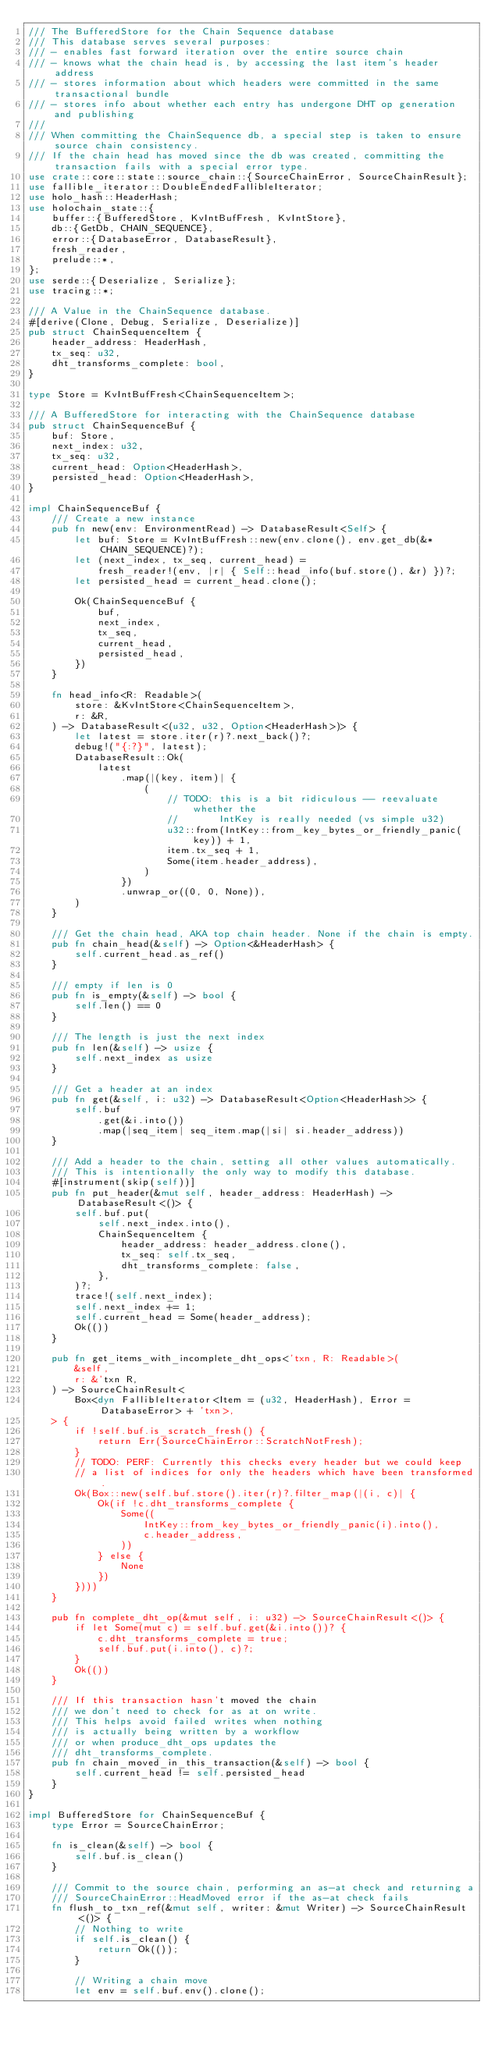<code> <loc_0><loc_0><loc_500><loc_500><_Rust_>/// The BufferedStore for the Chain Sequence database
/// This database serves several purposes:
/// - enables fast forward iteration over the entire source chain
/// - knows what the chain head is, by accessing the last item's header address
/// - stores information about which headers were committed in the same transactional bundle
/// - stores info about whether each entry has undergone DHT op generation and publishing
///
/// When committing the ChainSequence db, a special step is taken to ensure source chain consistency.
/// If the chain head has moved since the db was created, committing the transaction fails with a special error type.
use crate::core::state::source_chain::{SourceChainError, SourceChainResult};
use fallible_iterator::DoubleEndedFallibleIterator;
use holo_hash::HeaderHash;
use holochain_state::{
    buffer::{BufferedStore, KvIntBufFresh, KvIntStore},
    db::{GetDb, CHAIN_SEQUENCE},
    error::{DatabaseError, DatabaseResult},
    fresh_reader,
    prelude::*,
};
use serde::{Deserialize, Serialize};
use tracing::*;

/// A Value in the ChainSequence database.
#[derive(Clone, Debug, Serialize, Deserialize)]
pub struct ChainSequenceItem {
    header_address: HeaderHash,
    tx_seq: u32,
    dht_transforms_complete: bool,
}

type Store = KvIntBufFresh<ChainSequenceItem>;

/// A BufferedStore for interacting with the ChainSequence database
pub struct ChainSequenceBuf {
    buf: Store,
    next_index: u32,
    tx_seq: u32,
    current_head: Option<HeaderHash>,
    persisted_head: Option<HeaderHash>,
}

impl ChainSequenceBuf {
    /// Create a new instance
    pub fn new(env: EnvironmentRead) -> DatabaseResult<Self> {
        let buf: Store = KvIntBufFresh::new(env.clone(), env.get_db(&*CHAIN_SEQUENCE)?);
        let (next_index, tx_seq, current_head) =
            fresh_reader!(env, |r| { Self::head_info(buf.store(), &r) })?;
        let persisted_head = current_head.clone();

        Ok(ChainSequenceBuf {
            buf,
            next_index,
            tx_seq,
            current_head,
            persisted_head,
        })
    }

    fn head_info<R: Readable>(
        store: &KvIntStore<ChainSequenceItem>,
        r: &R,
    ) -> DatabaseResult<(u32, u32, Option<HeaderHash>)> {
        let latest = store.iter(r)?.next_back()?;
        debug!("{:?}", latest);
        DatabaseResult::Ok(
            latest
                .map(|(key, item)| {
                    (
                        // TODO: this is a bit ridiculous -- reevaluate whether the
                        //       IntKey is really needed (vs simple u32)
                        u32::from(IntKey::from_key_bytes_or_friendly_panic(key)) + 1,
                        item.tx_seq + 1,
                        Some(item.header_address),
                    )
                })
                .unwrap_or((0, 0, None)),
        )
    }

    /// Get the chain head, AKA top chain header. None if the chain is empty.
    pub fn chain_head(&self) -> Option<&HeaderHash> {
        self.current_head.as_ref()
    }

    /// empty if len is 0
    pub fn is_empty(&self) -> bool {
        self.len() == 0
    }

    /// The length is just the next index
    pub fn len(&self) -> usize {
        self.next_index as usize
    }

    /// Get a header at an index
    pub fn get(&self, i: u32) -> DatabaseResult<Option<HeaderHash>> {
        self.buf
            .get(&i.into())
            .map(|seq_item| seq_item.map(|si| si.header_address))
    }

    /// Add a header to the chain, setting all other values automatically.
    /// This is intentionally the only way to modify this database.
    #[instrument(skip(self))]
    pub fn put_header(&mut self, header_address: HeaderHash) -> DatabaseResult<()> {
        self.buf.put(
            self.next_index.into(),
            ChainSequenceItem {
                header_address: header_address.clone(),
                tx_seq: self.tx_seq,
                dht_transforms_complete: false,
            },
        )?;
        trace!(self.next_index);
        self.next_index += 1;
        self.current_head = Some(header_address);
        Ok(())
    }

    pub fn get_items_with_incomplete_dht_ops<'txn, R: Readable>(
        &self,
        r: &'txn R,
    ) -> SourceChainResult<
        Box<dyn FallibleIterator<Item = (u32, HeaderHash), Error = DatabaseError> + 'txn>,
    > {
        if !self.buf.is_scratch_fresh() {
            return Err(SourceChainError::ScratchNotFresh);
        }
        // TODO: PERF: Currently this checks every header but we could keep
        // a list of indices for only the headers which have been transformed.
        Ok(Box::new(self.buf.store().iter(r)?.filter_map(|(i, c)| {
            Ok(if !c.dht_transforms_complete {
                Some((
                    IntKey::from_key_bytes_or_friendly_panic(i).into(),
                    c.header_address,
                ))
            } else {
                None
            })
        })))
    }

    pub fn complete_dht_op(&mut self, i: u32) -> SourceChainResult<()> {
        if let Some(mut c) = self.buf.get(&i.into())? {
            c.dht_transforms_complete = true;
            self.buf.put(i.into(), c)?;
        }
        Ok(())
    }

    /// If this transaction hasn't moved the chain
    /// we don't need to check for as at on write.
    /// This helps avoid failed writes when nothing
    /// is actually being written by a workflow
    /// or when produce_dht_ops updates the
    /// dht_transforms_complete.
    pub fn chain_moved_in_this_transaction(&self) -> bool {
        self.current_head != self.persisted_head
    }
}

impl BufferedStore for ChainSequenceBuf {
    type Error = SourceChainError;

    fn is_clean(&self) -> bool {
        self.buf.is_clean()
    }

    /// Commit to the source chain, performing an as-at check and returning a
    /// SourceChainError::HeadMoved error if the as-at check fails
    fn flush_to_txn_ref(&mut self, writer: &mut Writer) -> SourceChainResult<()> {
        // Nothing to write
        if self.is_clean() {
            return Ok(());
        }

        // Writing a chain move
        let env = self.buf.env().clone();</code> 